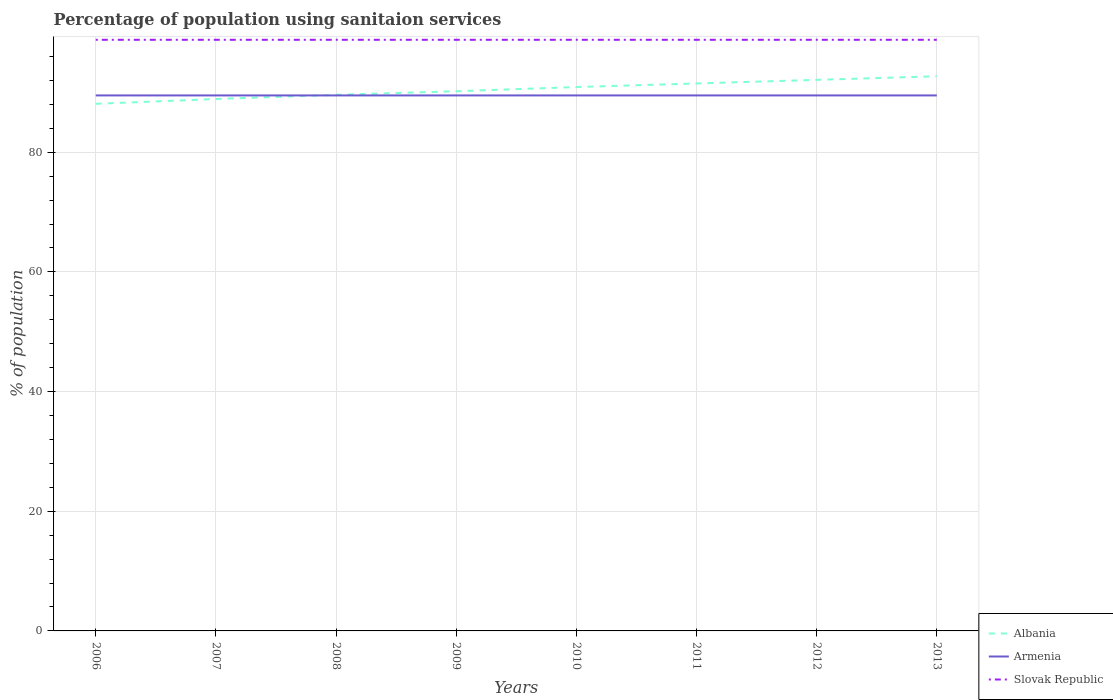How many different coloured lines are there?
Your answer should be compact. 3. Does the line corresponding to Albania intersect with the line corresponding to Slovak Republic?
Make the answer very short. No. Is the number of lines equal to the number of legend labels?
Make the answer very short. Yes. Across all years, what is the maximum percentage of population using sanitaion services in Armenia?
Ensure brevity in your answer.  89.5. What is the difference between the highest and the second highest percentage of population using sanitaion services in Albania?
Your response must be concise. 4.6. Is the percentage of population using sanitaion services in Albania strictly greater than the percentage of population using sanitaion services in Slovak Republic over the years?
Keep it short and to the point. Yes. How many years are there in the graph?
Offer a terse response. 8. What is the difference between two consecutive major ticks on the Y-axis?
Keep it short and to the point. 20. Are the values on the major ticks of Y-axis written in scientific E-notation?
Ensure brevity in your answer.  No. Does the graph contain any zero values?
Make the answer very short. No. How are the legend labels stacked?
Ensure brevity in your answer.  Vertical. What is the title of the graph?
Make the answer very short. Percentage of population using sanitaion services. Does "Portugal" appear as one of the legend labels in the graph?
Make the answer very short. No. What is the label or title of the Y-axis?
Keep it short and to the point. % of population. What is the % of population of Albania in 2006?
Offer a very short reply. 88.1. What is the % of population in Armenia in 2006?
Your response must be concise. 89.5. What is the % of population in Slovak Republic in 2006?
Your answer should be very brief. 98.8. What is the % of population of Albania in 2007?
Keep it short and to the point. 88.9. What is the % of population in Armenia in 2007?
Your response must be concise. 89.5. What is the % of population of Slovak Republic in 2007?
Offer a very short reply. 98.8. What is the % of population of Albania in 2008?
Provide a short and direct response. 89.6. What is the % of population of Armenia in 2008?
Ensure brevity in your answer.  89.5. What is the % of population of Slovak Republic in 2008?
Provide a succinct answer. 98.8. What is the % of population of Albania in 2009?
Give a very brief answer. 90.2. What is the % of population in Armenia in 2009?
Your answer should be compact. 89.5. What is the % of population in Slovak Republic in 2009?
Give a very brief answer. 98.8. What is the % of population in Albania in 2010?
Ensure brevity in your answer.  90.9. What is the % of population of Armenia in 2010?
Provide a short and direct response. 89.5. What is the % of population in Slovak Republic in 2010?
Your answer should be very brief. 98.8. What is the % of population in Albania in 2011?
Offer a terse response. 91.5. What is the % of population in Armenia in 2011?
Give a very brief answer. 89.5. What is the % of population in Slovak Republic in 2011?
Keep it short and to the point. 98.8. What is the % of population of Albania in 2012?
Provide a short and direct response. 92.1. What is the % of population of Armenia in 2012?
Your response must be concise. 89.5. What is the % of population in Slovak Republic in 2012?
Make the answer very short. 98.8. What is the % of population in Albania in 2013?
Your response must be concise. 92.7. What is the % of population in Armenia in 2013?
Give a very brief answer. 89.5. What is the % of population in Slovak Republic in 2013?
Ensure brevity in your answer.  98.8. Across all years, what is the maximum % of population of Albania?
Keep it short and to the point. 92.7. Across all years, what is the maximum % of population of Armenia?
Offer a terse response. 89.5. Across all years, what is the maximum % of population of Slovak Republic?
Your answer should be compact. 98.8. Across all years, what is the minimum % of population in Albania?
Give a very brief answer. 88.1. Across all years, what is the minimum % of population in Armenia?
Offer a very short reply. 89.5. Across all years, what is the minimum % of population in Slovak Republic?
Ensure brevity in your answer.  98.8. What is the total % of population in Albania in the graph?
Offer a very short reply. 724. What is the total % of population of Armenia in the graph?
Offer a very short reply. 716. What is the total % of population of Slovak Republic in the graph?
Provide a succinct answer. 790.4. What is the difference between the % of population in Albania in 2006 and that in 2007?
Your answer should be very brief. -0.8. What is the difference between the % of population in Armenia in 2006 and that in 2007?
Your response must be concise. 0. What is the difference between the % of population in Slovak Republic in 2006 and that in 2007?
Your answer should be very brief. 0. What is the difference between the % of population in Albania in 2006 and that in 2008?
Offer a very short reply. -1.5. What is the difference between the % of population of Armenia in 2006 and that in 2008?
Give a very brief answer. 0. What is the difference between the % of population in Slovak Republic in 2006 and that in 2008?
Give a very brief answer. 0. What is the difference between the % of population in Albania in 2006 and that in 2009?
Make the answer very short. -2.1. What is the difference between the % of population in Slovak Republic in 2006 and that in 2009?
Offer a very short reply. 0. What is the difference between the % of population of Albania in 2006 and that in 2011?
Offer a terse response. -3.4. What is the difference between the % of population of Albania in 2006 and that in 2012?
Make the answer very short. -4. What is the difference between the % of population of Armenia in 2006 and that in 2012?
Offer a very short reply. 0. What is the difference between the % of population in Slovak Republic in 2006 and that in 2012?
Offer a very short reply. 0. What is the difference between the % of population in Slovak Republic in 2006 and that in 2013?
Keep it short and to the point. 0. What is the difference between the % of population in Armenia in 2007 and that in 2008?
Ensure brevity in your answer.  0. What is the difference between the % of population in Albania in 2007 and that in 2009?
Offer a very short reply. -1.3. What is the difference between the % of population in Armenia in 2007 and that in 2009?
Make the answer very short. 0. What is the difference between the % of population in Albania in 2007 and that in 2010?
Keep it short and to the point. -2. What is the difference between the % of population in Slovak Republic in 2007 and that in 2010?
Offer a very short reply. 0. What is the difference between the % of population in Albania in 2007 and that in 2011?
Make the answer very short. -2.6. What is the difference between the % of population of Armenia in 2007 and that in 2012?
Offer a terse response. 0. What is the difference between the % of population of Albania in 2007 and that in 2013?
Your answer should be compact. -3.8. What is the difference between the % of population of Armenia in 2007 and that in 2013?
Provide a short and direct response. 0. What is the difference between the % of population of Armenia in 2008 and that in 2009?
Your answer should be very brief. 0. What is the difference between the % of population of Albania in 2008 and that in 2010?
Provide a succinct answer. -1.3. What is the difference between the % of population of Armenia in 2008 and that in 2010?
Offer a terse response. 0. What is the difference between the % of population of Slovak Republic in 2008 and that in 2010?
Provide a short and direct response. 0. What is the difference between the % of population of Armenia in 2008 and that in 2011?
Offer a terse response. 0. What is the difference between the % of population in Albania in 2008 and that in 2012?
Your answer should be very brief. -2.5. What is the difference between the % of population of Slovak Republic in 2008 and that in 2013?
Offer a terse response. 0. What is the difference between the % of population in Albania in 2009 and that in 2010?
Make the answer very short. -0.7. What is the difference between the % of population in Armenia in 2009 and that in 2010?
Provide a short and direct response. 0. What is the difference between the % of population of Armenia in 2009 and that in 2011?
Offer a very short reply. 0. What is the difference between the % of population of Albania in 2009 and that in 2013?
Make the answer very short. -2.5. What is the difference between the % of population in Armenia in 2009 and that in 2013?
Ensure brevity in your answer.  0. What is the difference between the % of population in Slovak Republic in 2009 and that in 2013?
Give a very brief answer. 0. What is the difference between the % of population of Albania in 2010 and that in 2011?
Offer a very short reply. -0.6. What is the difference between the % of population in Albania in 2010 and that in 2012?
Provide a short and direct response. -1.2. What is the difference between the % of population of Armenia in 2010 and that in 2012?
Make the answer very short. 0. What is the difference between the % of population of Armenia in 2010 and that in 2013?
Provide a succinct answer. 0. What is the difference between the % of population of Slovak Republic in 2010 and that in 2013?
Offer a very short reply. 0. What is the difference between the % of population of Armenia in 2011 and that in 2012?
Keep it short and to the point. 0. What is the difference between the % of population of Slovak Republic in 2011 and that in 2012?
Provide a succinct answer. 0. What is the difference between the % of population of Armenia in 2011 and that in 2013?
Offer a very short reply. 0. What is the difference between the % of population of Slovak Republic in 2011 and that in 2013?
Give a very brief answer. 0. What is the difference between the % of population in Albania in 2012 and that in 2013?
Give a very brief answer. -0.6. What is the difference between the % of population of Armenia in 2012 and that in 2013?
Offer a very short reply. 0. What is the difference between the % of population in Slovak Republic in 2012 and that in 2013?
Provide a succinct answer. 0. What is the difference between the % of population of Albania in 2006 and the % of population of Armenia in 2007?
Your answer should be compact. -1.4. What is the difference between the % of population in Albania in 2006 and the % of population in Slovak Republic in 2008?
Offer a very short reply. -10.7. What is the difference between the % of population of Armenia in 2006 and the % of population of Slovak Republic in 2008?
Offer a very short reply. -9.3. What is the difference between the % of population of Albania in 2006 and the % of population of Slovak Republic in 2009?
Ensure brevity in your answer.  -10.7. What is the difference between the % of population in Albania in 2006 and the % of population in Armenia in 2010?
Your answer should be very brief. -1.4. What is the difference between the % of population of Albania in 2006 and the % of population of Slovak Republic in 2012?
Your answer should be compact. -10.7. What is the difference between the % of population of Armenia in 2006 and the % of population of Slovak Republic in 2012?
Your answer should be very brief. -9.3. What is the difference between the % of population of Albania in 2006 and the % of population of Armenia in 2013?
Your answer should be very brief. -1.4. What is the difference between the % of population of Albania in 2007 and the % of population of Armenia in 2008?
Keep it short and to the point. -0.6. What is the difference between the % of population of Albania in 2007 and the % of population of Slovak Republic in 2008?
Keep it short and to the point. -9.9. What is the difference between the % of population in Albania in 2007 and the % of population in Slovak Republic in 2009?
Keep it short and to the point. -9.9. What is the difference between the % of population in Armenia in 2007 and the % of population in Slovak Republic in 2009?
Ensure brevity in your answer.  -9.3. What is the difference between the % of population of Albania in 2007 and the % of population of Slovak Republic in 2010?
Your answer should be compact. -9.9. What is the difference between the % of population in Armenia in 2007 and the % of population in Slovak Republic in 2010?
Offer a very short reply. -9.3. What is the difference between the % of population of Albania in 2007 and the % of population of Armenia in 2011?
Provide a succinct answer. -0.6. What is the difference between the % of population in Albania in 2007 and the % of population in Slovak Republic in 2011?
Provide a succinct answer. -9.9. What is the difference between the % of population in Armenia in 2007 and the % of population in Slovak Republic in 2011?
Provide a succinct answer. -9.3. What is the difference between the % of population in Albania in 2007 and the % of population in Slovak Republic in 2012?
Provide a succinct answer. -9.9. What is the difference between the % of population of Albania in 2007 and the % of population of Armenia in 2013?
Offer a very short reply. -0.6. What is the difference between the % of population of Albania in 2007 and the % of population of Slovak Republic in 2013?
Your response must be concise. -9.9. What is the difference between the % of population of Albania in 2008 and the % of population of Armenia in 2010?
Ensure brevity in your answer.  0.1. What is the difference between the % of population in Albania in 2008 and the % of population in Slovak Republic in 2010?
Your answer should be very brief. -9.2. What is the difference between the % of population in Armenia in 2008 and the % of population in Slovak Republic in 2010?
Keep it short and to the point. -9.3. What is the difference between the % of population in Armenia in 2008 and the % of population in Slovak Republic in 2011?
Keep it short and to the point. -9.3. What is the difference between the % of population in Albania in 2008 and the % of population in Armenia in 2012?
Your response must be concise. 0.1. What is the difference between the % of population of Albania in 2008 and the % of population of Slovak Republic in 2013?
Provide a short and direct response. -9.2. What is the difference between the % of population of Armenia in 2008 and the % of population of Slovak Republic in 2013?
Your answer should be compact. -9.3. What is the difference between the % of population of Albania in 2009 and the % of population of Slovak Republic in 2010?
Your answer should be compact. -8.6. What is the difference between the % of population in Armenia in 2009 and the % of population in Slovak Republic in 2010?
Ensure brevity in your answer.  -9.3. What is the difference between the % of population of Albania in 2009 and the % of population of Armenia in 2011?
Your response must be concise. 0.7. What is the difference between the % of population of Albania in 2009 and the % of population of Slovak Republic in 2011?
Your answer should be compact. -8.6. What is the difference between the % of population of Armenia in 2009 and the % of population of Slovak Republic in 2011?
Offer a very short reply. -9.3. What is the difference between the % of population in Albania in 2009 and the % of population in Armenia in 2012?
Offer a very short reply. 0.7. What is the difference between the % of population in Armenia in 2009 and the % of population in Slovak Republic in 2012?
Make the answer very short. -9.3. What is the difference between the % of population of Albania in 2009 and the % of population of Slovak Republic in 2013?
Provide a short and direct response. -8.6. What is the difference between the % of population of Armenia in 2010 and the % of population of Slovak Republic in 2011?
Provide a succinct answer. -9.3. What is the difference between the % of population in Armenia in 2010 and the % of population in Slovak Republic in 2012?
Provide a short and direct response. -9.3. What is the difference between the % of population of Albania in 2010 and the % of population of Armenia in 2013?
Offer a very short reply. 1.4. What is the difference between the % of population in Albania in 2010 and the % of population in Slovak Republic in 2013?
Provide a succinct answer. -7.9. What is the difference between the % of population of Armenia in 2010 and the % of population of Slovak Republic in 2013?
Your response must be concise. -9.3. What is the difference between the % of population of Albania in 2011 and the % of population of Armenia in 2012?
Your answer should be compact. 2. What is the difference between the % of population in Albania in 2011 and the % of population in Slovak Republic in 2013?
Offer a very short reply. -7.3. What is the difference between the % of population in Armenia in 2011 and the % of population in Slovak Republic in 2013?
Give a very brief answer. -9.3. What is the difference between the % of population in Albania in 2012 and the % of population in Slovak Republic in 2013?
Ensure brevity in your answer.  -6.7. What is the difference between the % of population of Armenia in 2012 and the % of population of Slovak Republic in 2013?
Provide a short and direct response. -9.3. What is the average % of population in Albania per year?
Ensure brevity in your answer.  90.5. What is the average % of population of Armenia per year?
Offer a very short reply. 89.5. What is the average % of population in Slovak Republic per year?
Give a very brief answer. 98.8. In the year 2006, what is the difference between the % of population of Albania and % of population of Armenia?
Make the answer very short. -1.4. In the year 2006, what is the difference between the % of population in Armenia and % of population in Slovak Republic?
Provide a succinct answer. -9.3. In the year 2007, what is the difference between the % of population of Albania and % of population of Armenia?
Give a very brief answer. -0.6. In the year 2008, what is the difference between the % of population of Albania and % of population of Armenia?
Provide a short and direct response. 0.1. In the year 2009, what is the difference between the % of population in Albania and % of population in Armenia?
Keep it short and to the point. 0.7. In the year 2009, what is the difference between the % of population in Albania and % of population in Slovak Republic?
Provide a short and direct response. -8.6. In the year 2010, what is the difference between the % of population in Albania and % of population in Slovak Republic?
Your answer should be very brief. -7.9. In the year 2011, what is the difference between the % of population in Albania and % of population in Armenia?
Give a very brief answer. 2. In the year 2011, what is the difference between the % of population in Armenia and % of population in Slovak Republic?
Your response must be concise. -9.3. In the year 2013, what is the difference between the % of population in Albania and % of population in Armenia?
Offer a very short reply. 3.2. In the year 2013, what is the difference between the % of population of Albania and % of population of Slovak Republic?
Make the answer very short. -6.1. What is the ratio of the % of population of Albania in 2006 to that in 2008?
Keep it short and to the point. 0.98. What is the ratio of the % of population of Slovak Republic in 2006 to that in 2008?
Your response must be concise. 1. What is the ratio of the % of population in Albania in 2006 to that in 2009?
Ensure brevity in your answer.  0.98. What is the ratio of the % of population of Armenia in 2006 to that in 2009?
Provide a succinct answer. 1. What is the ratio of the % of population in Albania in 2006 to that in 2010?
Ensure brevity in your answer.  0.97. What is the ratio of the % of population in Albania in 2006 to that in 2011?
Offer a very short reply. 0.96. What is the ratio of the % of population of Albania in 2006 to that in 2012?
Offer a terse response. 0.96. What is the ratio of the % of population in Slovak Republic in 2006 to that in 2012?
Ensure brevity in your answer.  1. What is the ratio of the % of population in Albania in 2006 to that in 2013?
Offer a very short reply. 0.95. What is the ratio of the % of population of Slovak Republic in 2007 to that in 2008?
Make the answer very short. 1. What is the ratio of the % of population in Albania in 2007 to that in 2009?
Ensure brevity in your answer.  0.99. What is the ratio of the % of population in Slovak Republic in 2007 to that in 2009?
Ensure brevity in your answer.  1. What is the ratio of the % of population of Armenia in 2007 to that in 2010?
Make the answer very short. 1. What is the ratio of the % of population in Albania in 2007 to that in 2011?
Provide a succinct answer. 0.97. What is the ratio of the % of population of Armenia in 2007 to that in 2011?
Your answer should be compact. 1. What is the ratio of the % of population of Slovak Republic in 2007 to that in 2011?
Offer a terse response. 1. What is the ratio of the % of population of Albania in 2007 to that in 2012?
Offer a terse response. 0.97. What is the ratio of the % of population in Slovak Republic in 2007 to that in 2013?
Offer a very short reply. 1. What is the ratio of the % of population of Armenia in 2008 to that in 2009?
Ensure brevity in your answer.  1. What is the ratio of the % of population of Slovak Republic in 2008 to that in 2009?
Ensure brevity in your answer.  1. What is the ratio of the % of population of Albania in 2008 to that in 2010?
Make the answer very short. 0.99. What is the ratio of the % of population in Albania in 2008 to that in 2011?
Provide a short and direct response. 0.98. What is the ratio of the % of population of Armenia in 2008 to that in 2011?
Ensure brevity in your answer.  1. What is the ratio of the % of population in Albania in 2008 to that in 2012?
Provide a succinct answer. 0.97. What is the ratio of the % of population of Armenia in 2008 to that in 2012?
Give a very brief answer. 1. What is the ratio of the % of population of Albania in 2008 to that in 2013?
Make the answer very short. 0.97. What is the ratio of the % of population of Slovak Republic in 2008 to that in 2013?
Your answer should be compact. 1. What is the ratio of the % of population of Albania in 2009 to that in 2011?
Ensure brevity in your answer.  0.99. What is the ratio of the % of population in Albania in 2009 to that in 2012?
Your answer should be compact. 0.98. What is the ratio of the % of population in Armenia in 2009 to that in 2012?
Your answer should be compact. 1. What is the ratio of the % of population in Albania in 2009 to that in 2013?
Provide a short and direct response. 0.97. What is the ratio of the % of population of Albania in 2010 to that in 2011?
Ensure brevity in your answer.  0.99. What is the ratio of the % of population in Armenia in 2010 to that in 2011?
Your answer should be very brief. 1. What is the ratio of the % of population of Albania in 2010 to that in 2012?
Offer a very short reply. 0.99. What is the ratio of the % of population of Armenia in 2010 to that in 2012?
Provide a short and direct response. 1. What is the ratio of the % of population in Slovak Republic in 2010 to that in 2012?
Make the answer very short. 1. What is the ratio of the % of population of Albania in 2010 to that in 2013?
Provide a short and direct response. 0.98. What is the ratio of the % of population in Armenia in 2010 to that in 2013?
Keep it short and to the point. 1. What is the ratio of the % of population in Armenia in 2011 to that in 2012?
Your answer should be compact. 1. What is the ratio of the % of population in Albania in 2011 to that in 2013?
Offer a very short reply. 0.99. What is the ratio of the % of population in Slovak Republic in 2011 to that in 2013?
Offer a terse response. 1. What is the difference between the highest and the second highest % of population in Albania?
Keep it short and to the point. 0.6. What is the difference between the highest and the second highest % of population in Armenia?
Provide a succinct answer. 0. What is the difference between the highest and the second highest % of population of Slovak Republic?
Provide a short and direct response. 0. What is the difference between the highest and the lowest % of population in Albania?
Ensure brevity in your answer.  4.6. What is the difference between the highest and the lowest % of population in Armenia?
Keep it short and to the point. 0. What is the difference between the highest and the lowest % of population in Slovak Republic?
Keep it short and to the point. 0. 